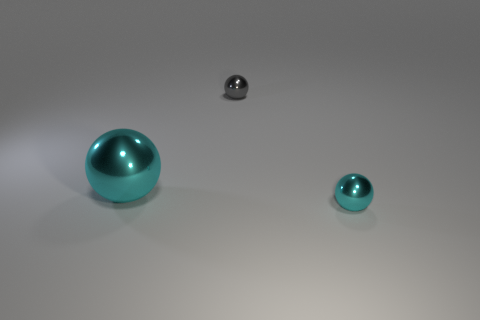Subtract all small gray metallic balls. How many balls are left? 2 Add 2 small gray spheres. How many objects exist? 5 Subtract all brown cubes. How many cyan balls are left? 2 Subtract all gray spheres. How many spheres are left? 2 Add 2 small green cylinders. How many small green cylinders exist? 2 Subtract 0 green blocks. How many objects are left? 3 Subtract 2 spheres. How many spheres are left? 1 Subtract all yellow spheres. Subtract all red cylinders. How many spheres are left? 3 Subtract all spheres. Subtract all big purple matte cubes. How many objects are left? 0 Add 3 big cyan spheres. How many big cyan spheres are left? 4 